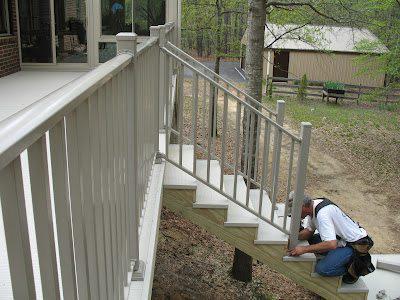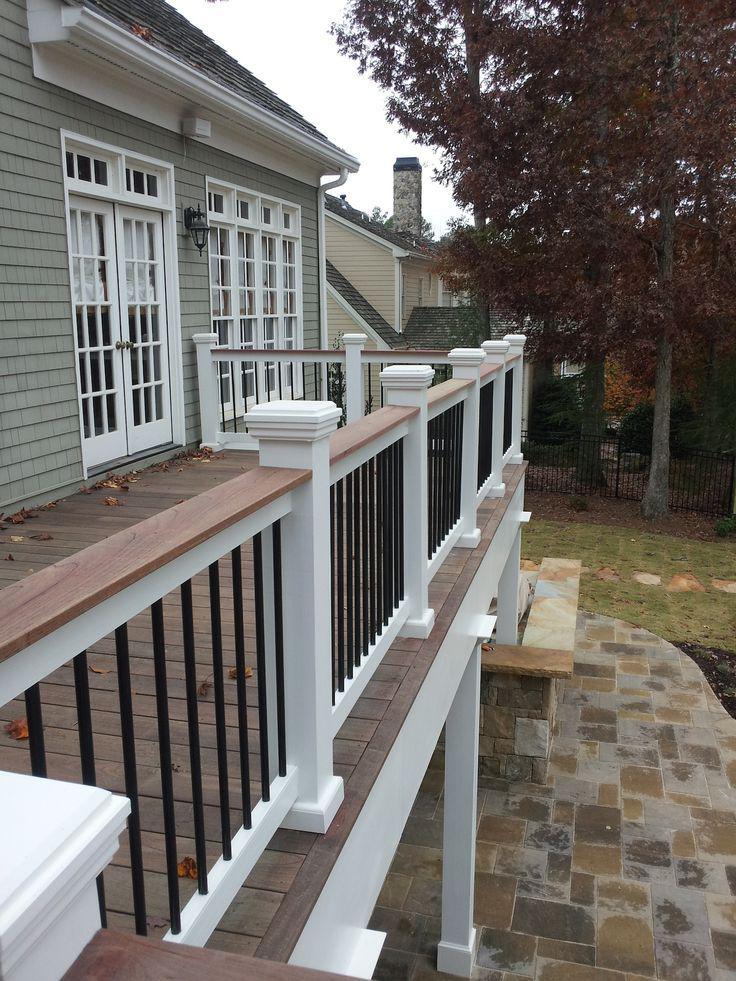The first image is the image on the left, the second image is the image on the right. For the images shown, is this caption "One of the railings has white main posts with smaller black posts in between." true? Answer yes or no. Yes. 